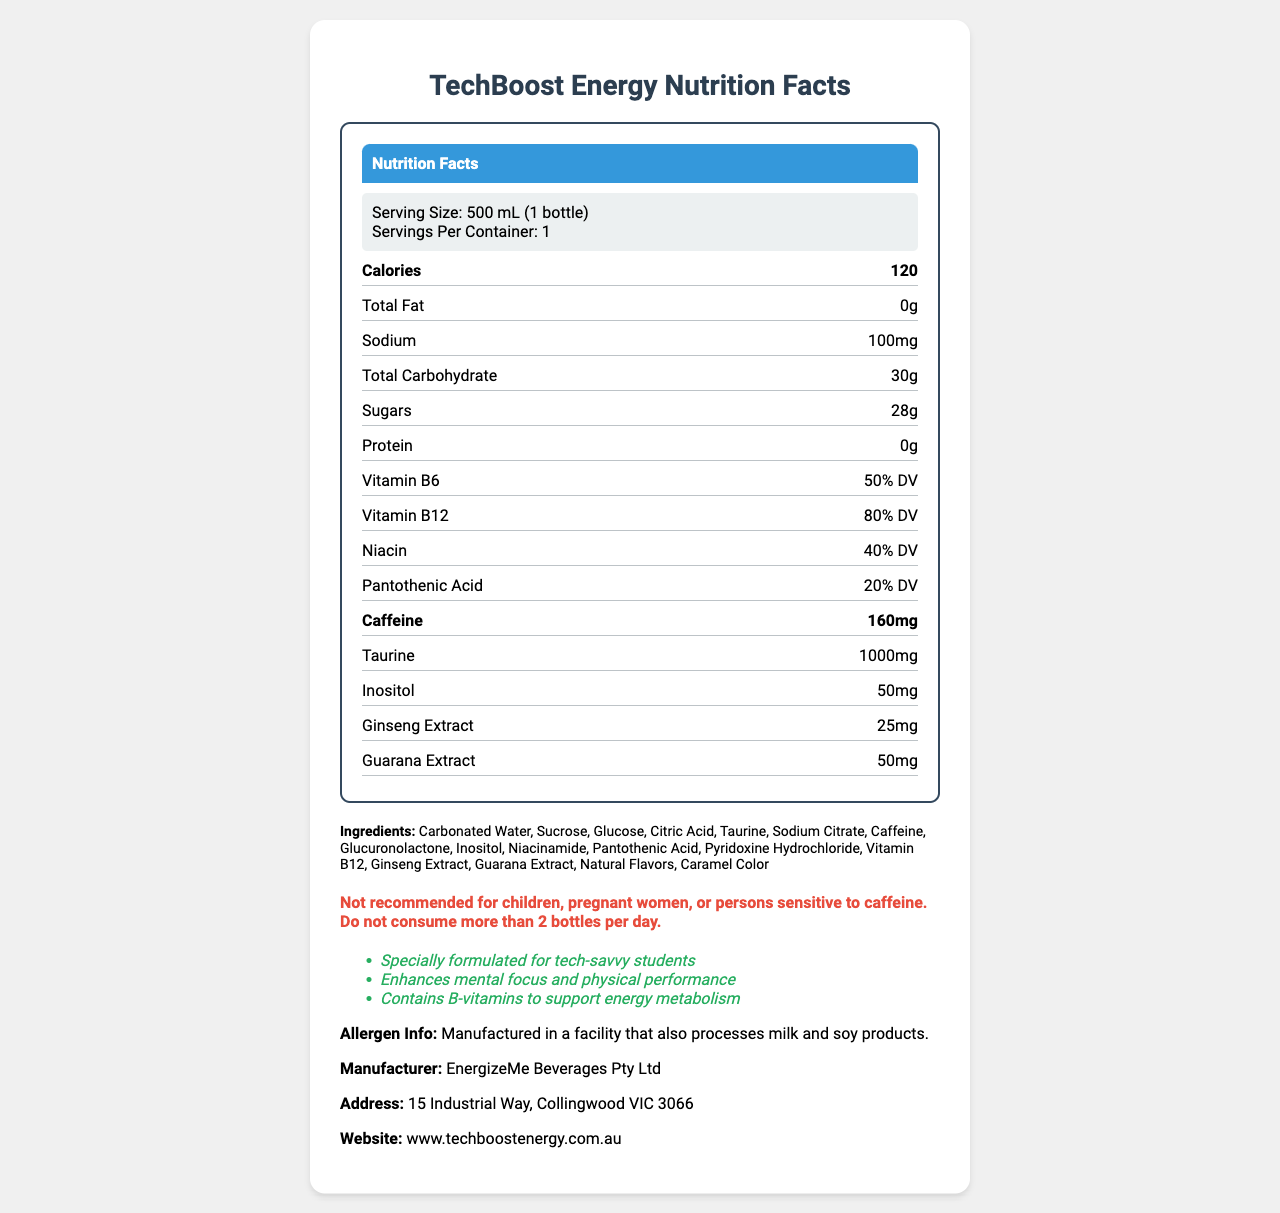who is the manufacturer of TechBoost Energy? The manufacturer information is listed towards the bottom of the document.
Answer: EnergizeMe Beverages Pty Ltd what is the serving size for TechBoost Energy? The serving size is specified at the top of the nutrition facts label under the section labelled *Serving Size*.
Answer: 500 mL (1 bottle) how much caffeine does one bottle of TechBoost Energy contain? The amount of caffeine is listed in the nutrient rows under the *Caffeine* section.
Answer: 160mg how many calories are in one bottle of TechBoost Energy? The calorie count is found near the top of the nutrient section, highlighted in a bold row.
Answer: 120 what is the sodium content in one serving of TechBoost Energy? The sodium content is listed in the nutrient rows, specifically under the *Sodium* section.
Answer: 100mg which vitamins are contained in TechBoost Energy and how much of the daily value do they provide? A. Vitamin A and Vitamin C B. Vitamin D and Vitamin E C. Vitamin B6 and Vitamin B12 D. Vitamin K and Vitamin B9 The document specifies the presence of Vitamin B6 (50% DV) and Vitamin B12 (80% DV) under the nutrients section.
Answer: C which ingredient is NOT found in TechBoost Energy? A. Taurine B. Ascorbic Acid C. Caffeine D. Citric Acid The list of ingredients includes Taurine, Caffeine, and Citric Acid but does not have Ascorbic Acid.
Answer: B does TechBoost Energy contain any fats? The nutrition facts label indicates *Total Fat* as 0g.
Answer: No is TechBoost Energy recommended for children? The warning section of the document clearly states that the product is not recommended for children, pregnant women, or persons sensitive to caffeine.
Answer: No summarize the main components of the TechBoost Energy nutrition label document. The document primarily lists the nutrition facts, ingredients, allergen information, manufacturer details, marketing claims, and a warning for the energy drink.
Answer: The document shows the nutrition facts for a sports energy drink called TechBoost Energy, popular among technical school students. It specifies that each 500 mL bottle contains 120 calories, 0g fat, 100mg sodium, 30g carbohydrates, including 28g sugars, and 0g protein. The drink is rich in B-vitamins and includes ingredients like Taurine, Caffeine, Ginseng Extract, and Guarana Extract. The warning advises against consumption by children and sensitive individuals, and the drink is marketed to enhance mental focus and physical performance. does TechBoost Energy contain any ingredients processed with milk and soy products? The document mentions that the product is manufactured in a facility that also processes milk and soy products, but it does not state whether any of the specific ingredients are processed with these allergens.
Answer: Cannot be determined 